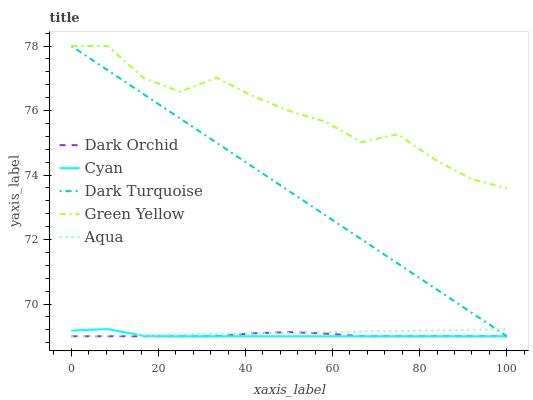Does Aqua have the minimum area under the curve?
Answer yes or no. No. Does Aqua have the maximum area under the curve?
Answer yes or no. No. Is Green Yellow the smoothest?
Answer yes or no. No. Is Aqua the roughest?
Answer yes or no. No. Does Green Yellow have the lowest value?
Answer yes or no. No. Does Aqua have the highest value?
Answer yes or no. No. Is Dark Orchid less than Green Yellow?
Answer yes or no. Yes. Is Green Yellow greater than Aqua?
Answer yes or no. Yes. Does Dark Orchid intersect Green Yellow?
Answer yes or no. No. 